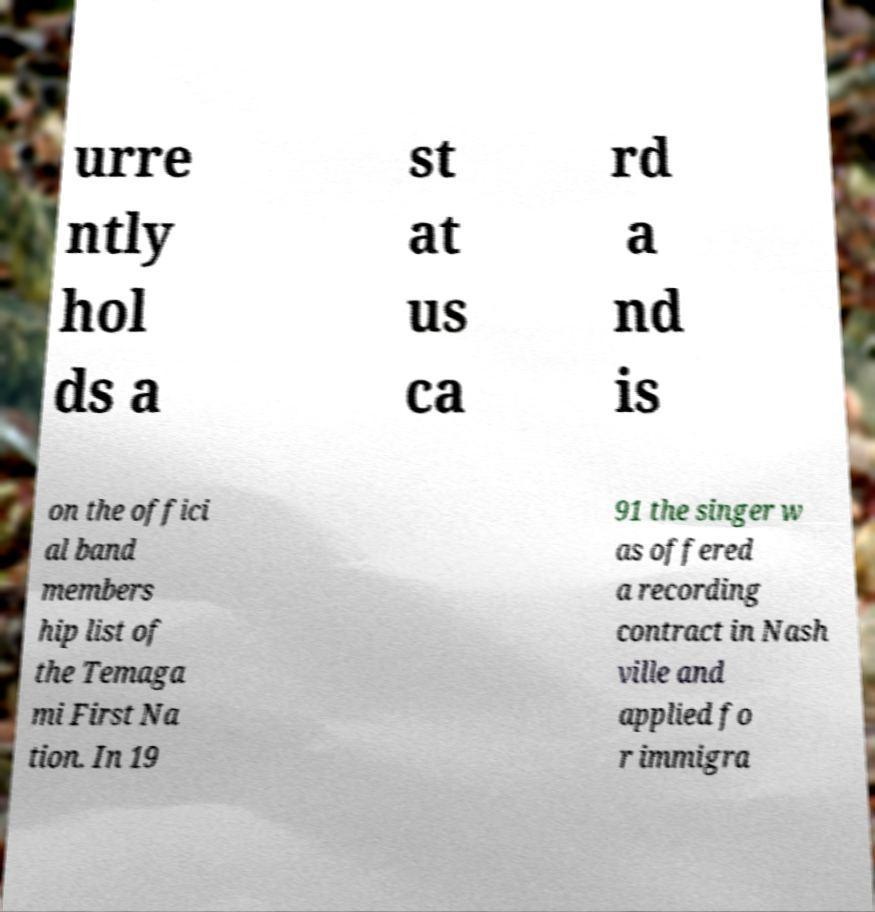Please read and relay the text visible in this image. What does it say? urre ntly hol ds a st at us ca rd a nd is on the offici al band members hip list of the Temaga mi First Na tion. In 19 91 the singer w as offered a recording contract in Nash ville and applied fo r immigra 